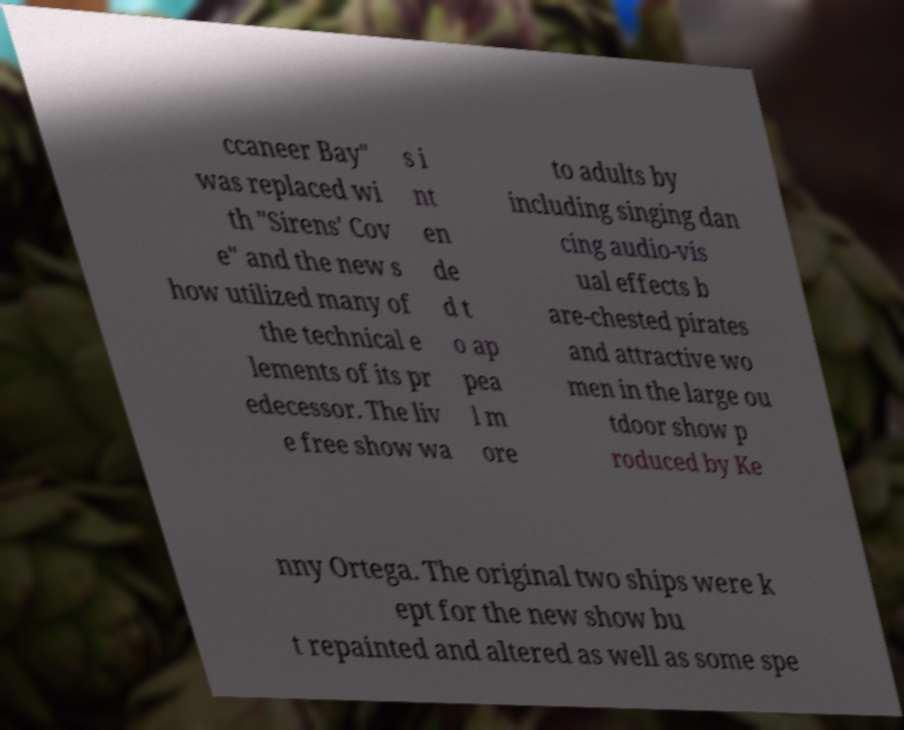Could you extract and type out the text from this image? ccaneer Bay" was replaced wi th "Sirens' Cov e" and the new s how utilized many of the technical e lements of its pr edecessor. The liv e free show wa s i nt en de d t o ap pea l m ore to adults by including singing dan cing audio-vis ual effects b are-chested pirates and attractive wo men in the large ou tdoor show p roduced by Ke nny Ortega. The original two ships were k ept for the new show bu t repainted and altered as well as some spe 